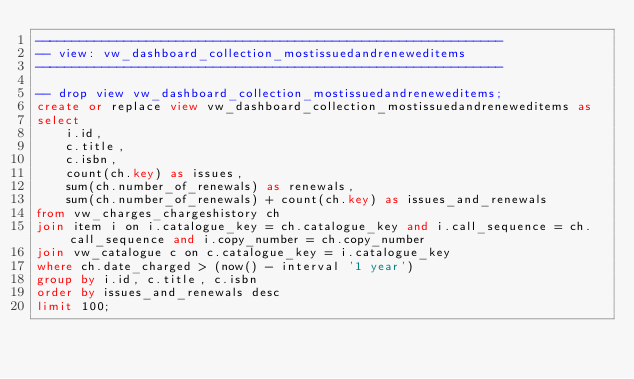<code> <loc_0><loc_0><loc_500><loc_500><_SQL_>---------------------------------------------------------------
-- view: vw_dashboard_collection_mostissuedandreneweditems
---------------------------------------------------------------

-- drop view vw_dashboard_collection_mostissuedandreneweditems;
create or replace view vw_dashboard_collection_mostissuedandreneweditems as 
select
    i.id,
    c.title,
    c.isbn,
    count(ch.key) as issues,
    sum(ch.number_of_renewals) as renewals,
    sum(ch.number_of_renewals) + count(ch.key) as issues_and_renewals
from vw_charges_chargeshistory ch
join item i on i.catalogue_key = ch.catalogue_key and i.call_sequence = ch.call_sequence and i.copy_number = ch.copy_number
join vw_catalogue c on c.catalogue_key = i.catalogue_key
where ch.date_charged > (now() - interval '1 year')
group by i.id, c.title, c.isbn
order by issues_and_renewals desc
limit 100;</code> 